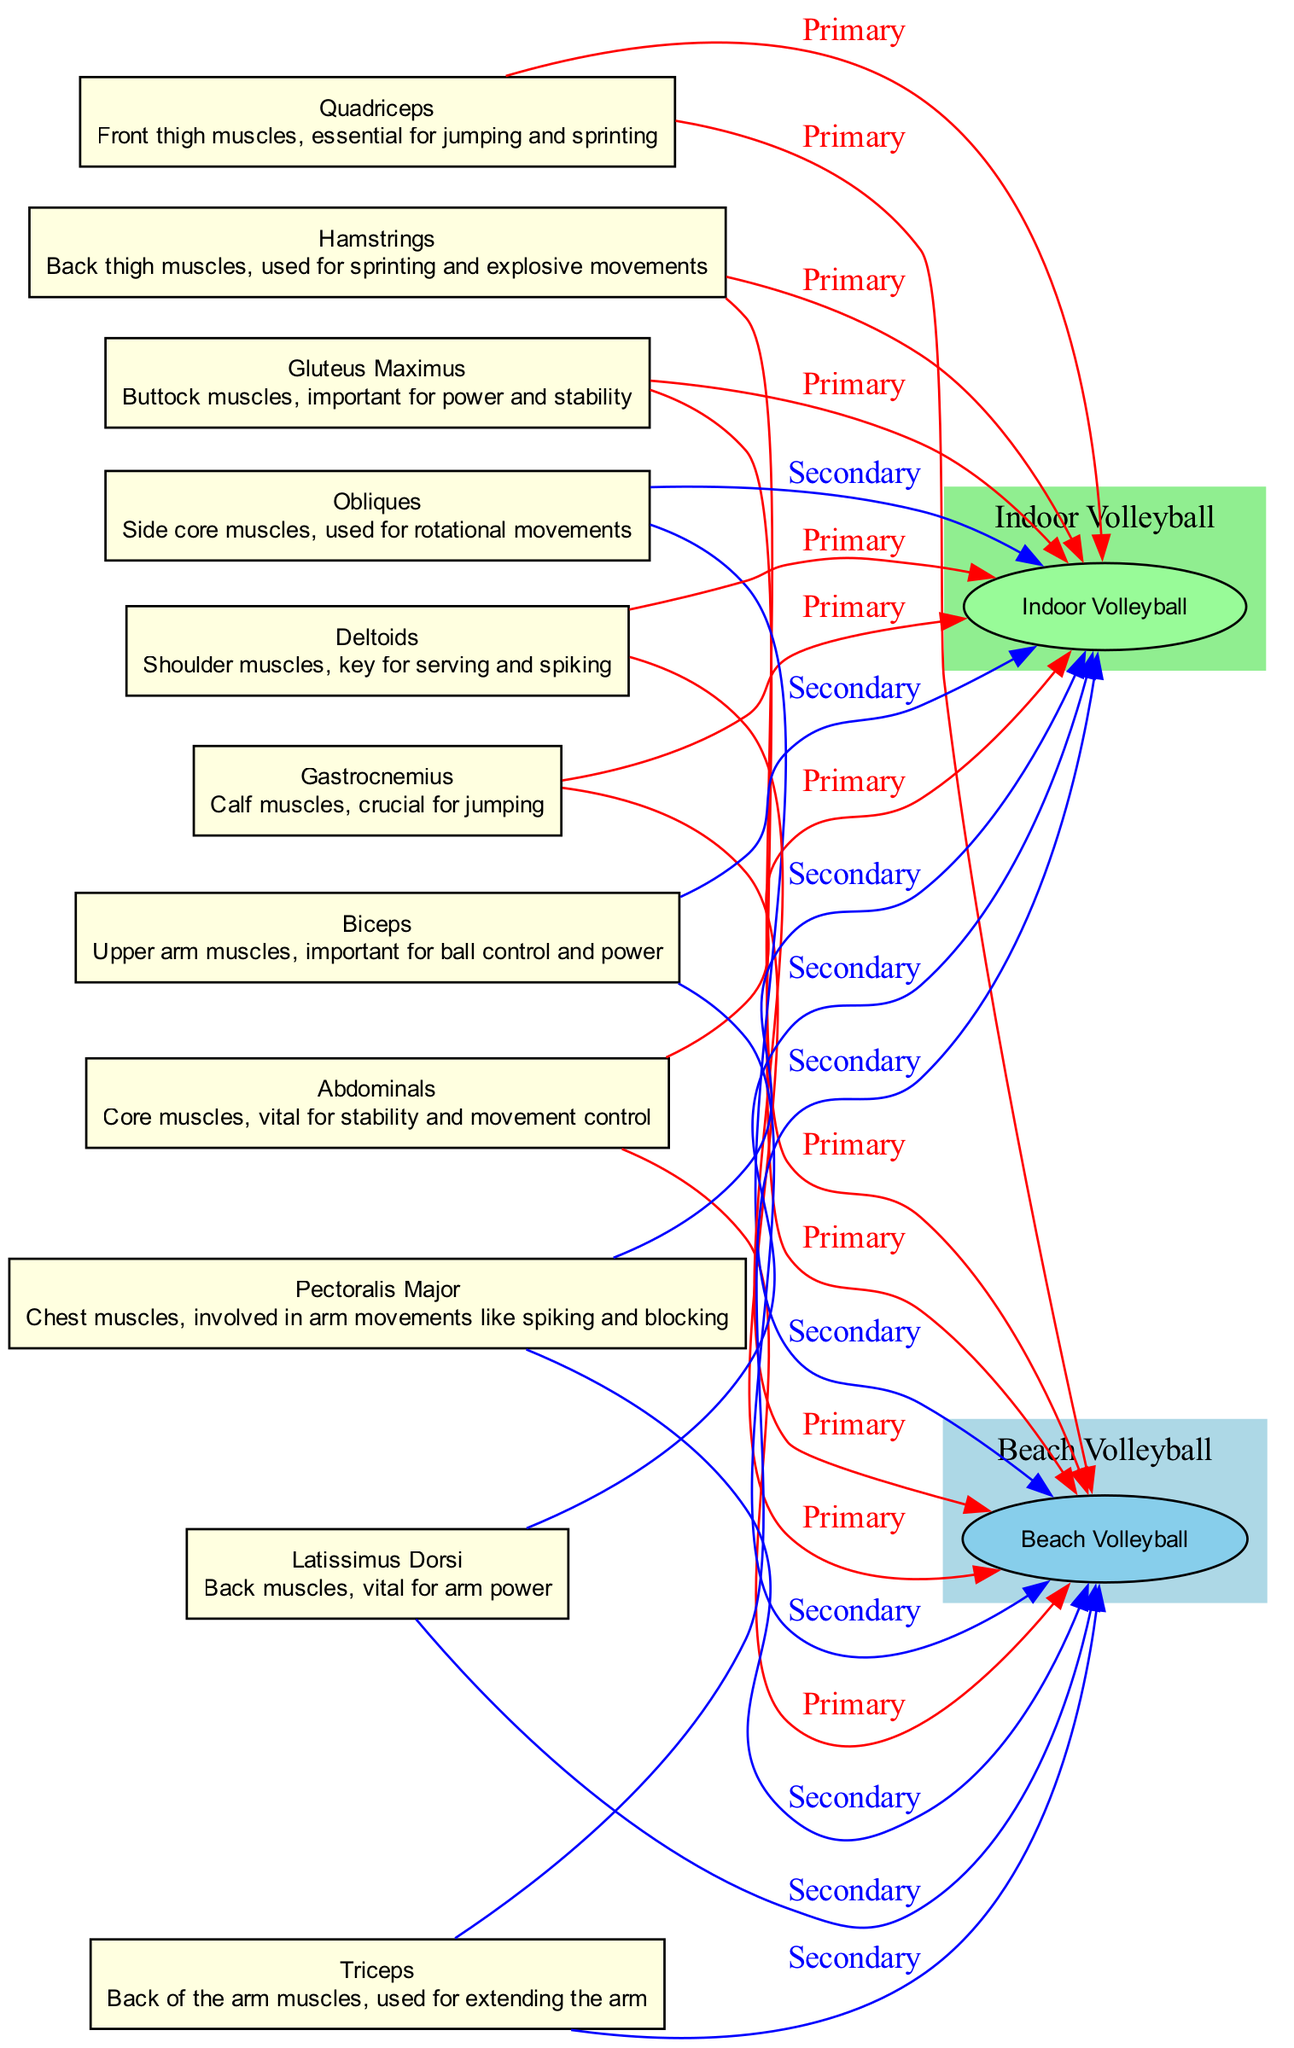What are the primary muscle groups engaged in Beach Volleyball? The diagram shows that the primary muscle groups engaged in Beach Volleyball are the Quadriceps, Hamstrings, Gastrocnemius, Gluteus Maximus, Abdominals, Deltoids, and others. I can identify these muscle groups by looking for the edges from each muscle to the Beach Volleyball node labeled as 'Primary'.
Answer: Quadriceps, Hamstrings, Gastrocnemius, Gluteus Maximus, Abdominals, Deltoids How many nodes represent muscle groups in the diagram? The diagram contains a total of 10 nodes representing various muscle groups: Quadriceps, Hamstrings, Gastrocnemius, Gluteus Maximus, Abdominals, Obliques, Deltoids, Pectoralis Major, Biceps, and Triceps. I counted each unique node listed in the diagram.
Answer: 10 Which muscle group has a key role in maintaining stamina on sand during Beach Volleyball? Referring to the edges from muscle groups to Beach Volleyball, the Gastrocnemius is highlighted as having a primary role in maintaining stamina regarding the sandy surface. The edge labeled 'Primary' indicates its significance in Beach Volleyball.
Answer: Gastrocnemius What muscle group is crucial for core stability in Indoor Volleyball? According to the diagram, the Abdominals are marked as a primary muscle group engaged in Indoor Volleyball for providing core stability. This is reflected by the direct edge from Abdominals to the Indoor Volleyball node.
Answer: Abdominals Which muscle provides stability and power during both Beach and Indoor Volleyball? The Gluteus Maximus serves to provide stability and power in both forms of volleyball. The diagram illustrates that it has primary connections to both Beach Volleyball and Indoor Volleyball, denoting its essential role in both contexts.
Answer: Gluteus Maximus How many muscle groups are primarily engaged in Indoor Volleyball? Upon examining the diagram, I find that six muscle groups are connected to the Indoor Volleyball node with edges labeled as 'Primary', including Quadriceps, Hamstrings, Gastrocnemius, Gluteus Maximus, Abdominals, and Deltoids. Counting the muscle groups with primary engagement shows a total of six.
Answer: 6 Which muscle groups are secondarily engaged in both types of volleyball? The diagram indicates that muscle groups like Obliques, Pectoralis Major, Biceps, Triceps, and Latissimus Dorsi have secondary engagement in both Beach and Indoor Volleyball, as denoted by edges labeled 'Secondary' leading to both volleyball nodes.
Answer: Obliques, Pectoralis Major, Biceps, Triceps, Latissimus Dorsi How is the engagement of the Deltoids different between Beach and Indoor Volleyball? The Deltoids are marked as a primary muscle group for both Beach and Indoor Volleyball, but their role is described as extensively used for strong serves and spikes in Beach Volleyball, whereas in Indoor Volleyball, they are key for powerful arm movements in a controlled environment. This difference in narrative highlights their specific roles in each type of volleyball.
Answer: Different roles Which muscle group is crucial for jumping in indoor volleyball? The diagram specifically identifies the Quadriceps as a primary muscle group engaged in Indoor Volleyball, which is critical for jumping. The edge labeled 'Primary' from Quadriceps to the Indoor Volleyball node makes this connection clear.
Answer: Quadriceps 